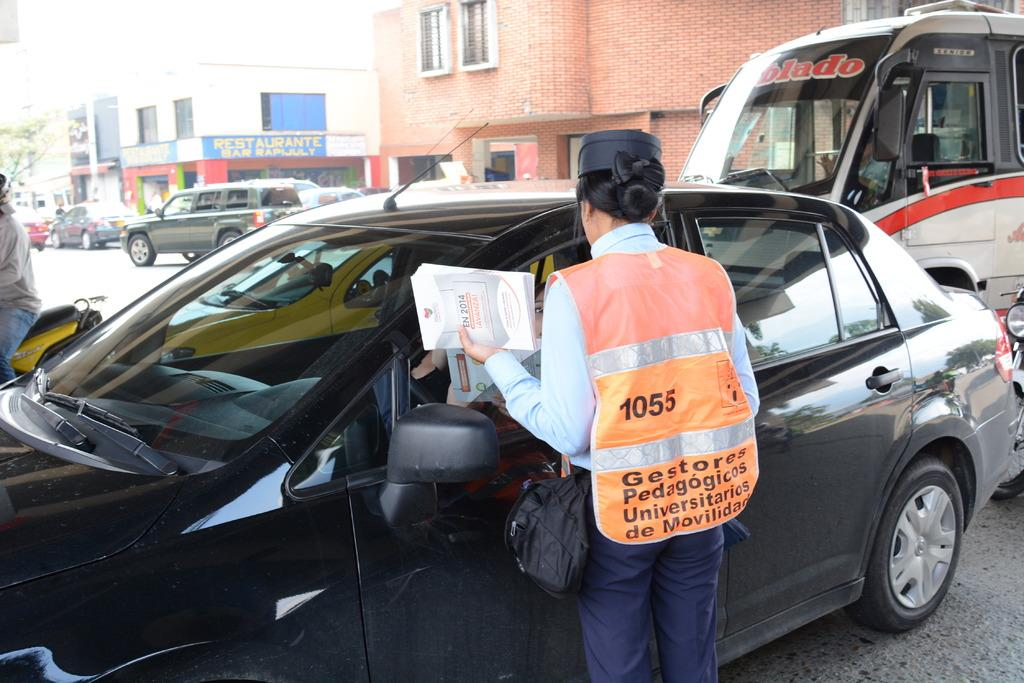<image>
Relay a brief, clear account of the picture shown. A woman wearing a reflecting vest is standing at the driver window of a car, across the street from a restaurant and bar. 